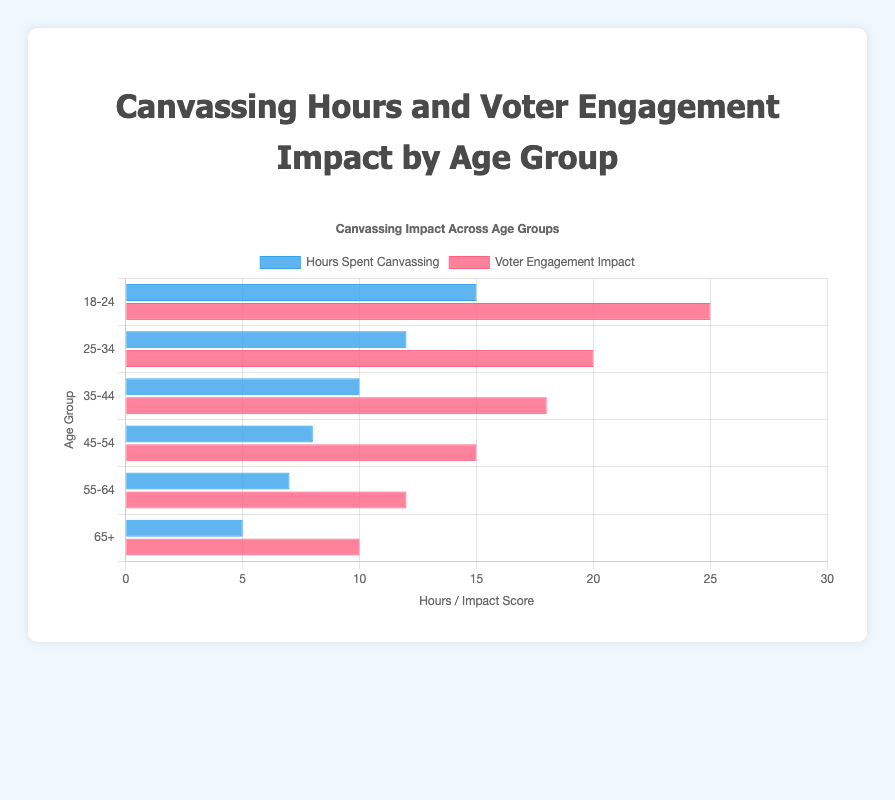What is the total number of hours spent canvassing by all age groups combined? Sum the hours spent canvassing for each age group: 15 (18-24) + 12 (25-34) + 10 (35-44) + 8 (45-54) + 7 (55-64) + 5 (65+) = 57
Answer: 57 Which age group has the highest voter engagement impact? Compare the voter engagement impact scores for each age group. The highest is 25, which corresponds to the 18-24 age group
Answer: 18-24 Which age group has the least hours spent canvassing? The age group with the smallest bar in the 'Hours Spent Canvassing' dataset is 65+, corresponding to 5 hours
Answer: 65+ Is the voter engagement impact for the 18-24 age group greater than the 55-64 age group? Compare the voter engagement impacts: 25 (18-24) vs 12 (55-64). 25 is greater than 12
Answer: Yes How much more engagement is there in the 18-24 group compared to the 25-34 group? Look at the voter engagement impacts: 25 (18-24) - 20 (25-34) = 5
Answer: 5 What is the average voter engagement impact across all age groups? The sum of the engagement impacts is 25 + 20 + 18 + 15 + 12 + 10 = 100. There are 6 age groups, so 100 / 6 ≈ 16.67
Answer: 16.67 Which dataset (Hours Spent Canvassing or Voter Engagement Impact) has more variability among age groups? Compare the range of values for each dataset: Hours (15 - 5 = 10) and Engagement (25 - 10 = 15). Voter Engagement Impact has a larger range of values
Answer: Voter Engagement Impact Are the hours spent canvassing directly proportional to the voter engagement impact for the 35-44 age group? The ratio of hours to engagement for 35-44 is 10:18. Direct proportionality would imply a consistent ratio, which isn't evident here based on diverse ratios among groups
Answer: No 